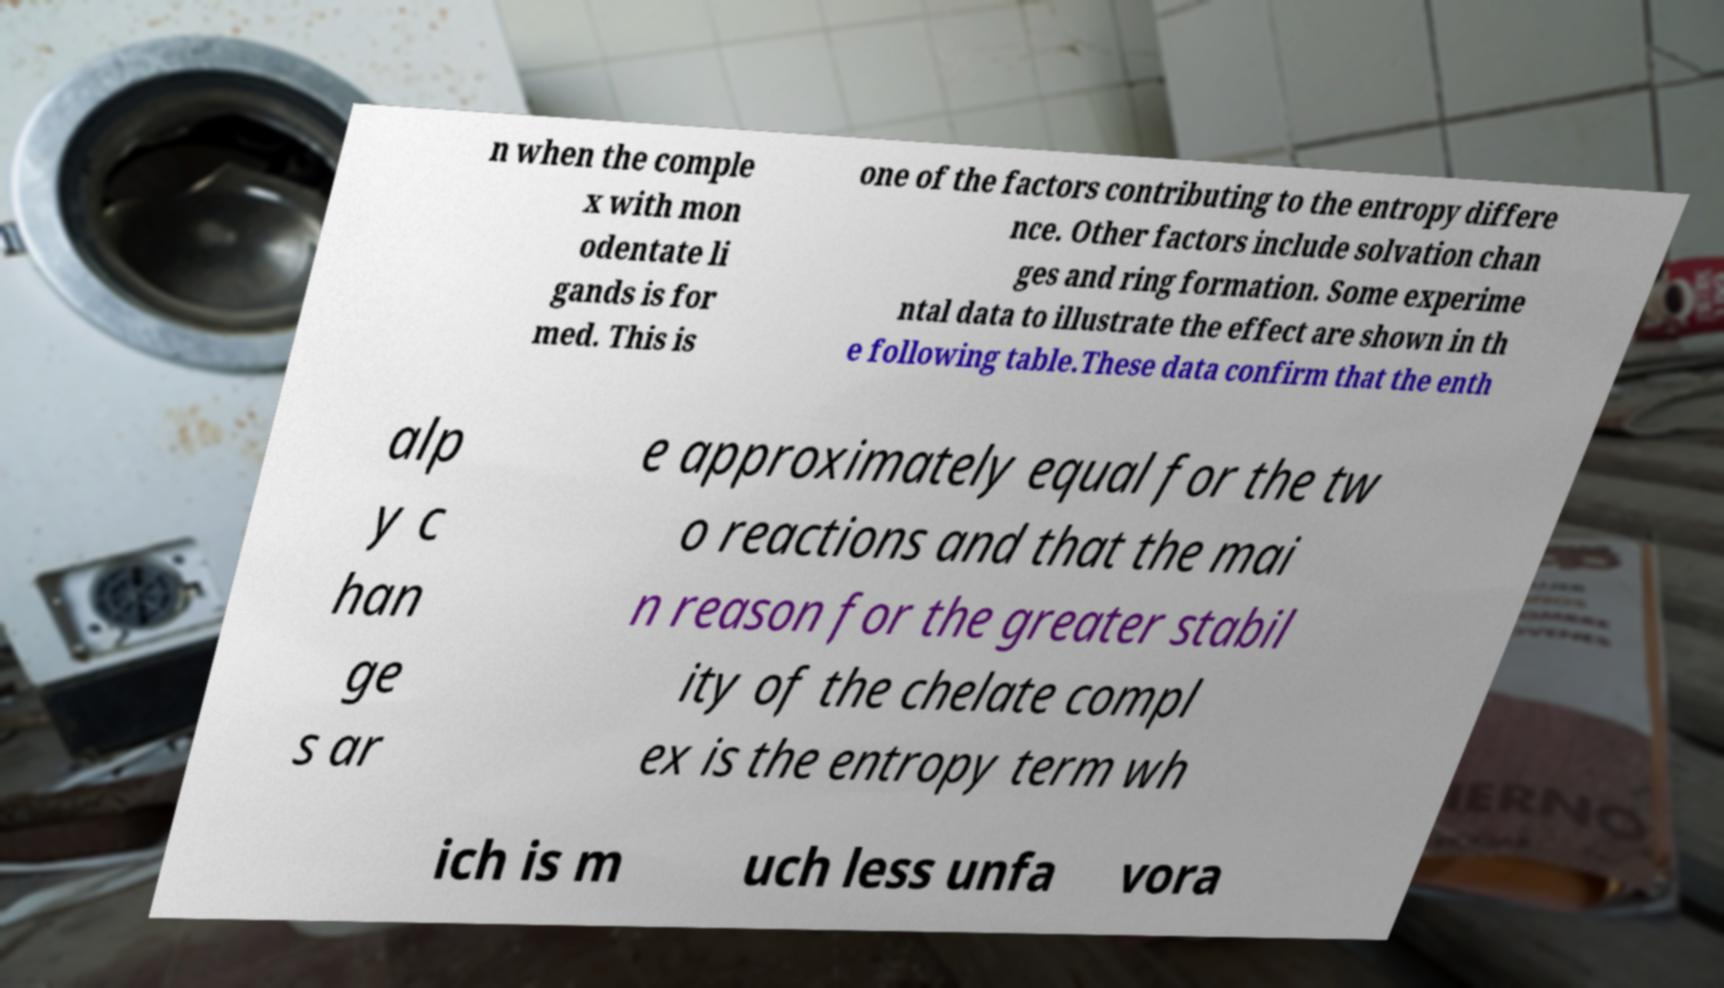There's text embedded in this image that I need extracted. Can you transcribe it verbatim? n when the comple x with mon odentate li gands is for med. This is one of the factors contributing to the entropy differe nce. Other factors include solvation chan ges and ring formation. Some experime ntal data to illustrate the effect are shown in th e following table.These data confirm that the enth alp y c han ge s ar e approximately equal for the tw o reactions and that the mai n reason for the greater stabil ity of the chelate compl ex is the entropy term wh ich is m uch less unfa vora 